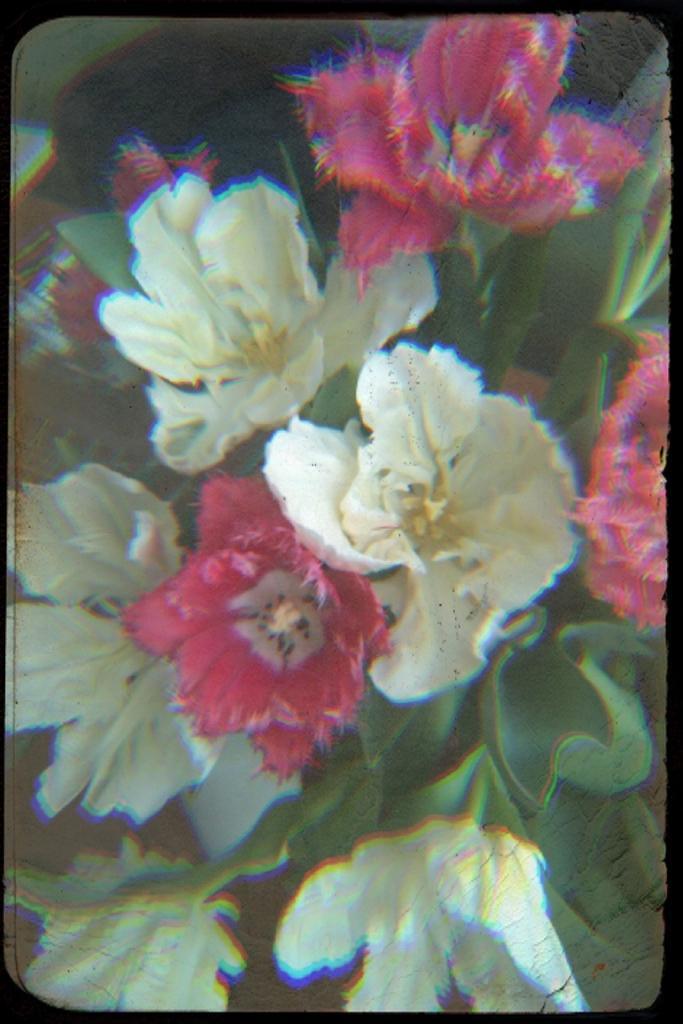Describe this image in one or two sentences. There are plants having white and pink color flowers and green color leaves. And the background is blurred. 